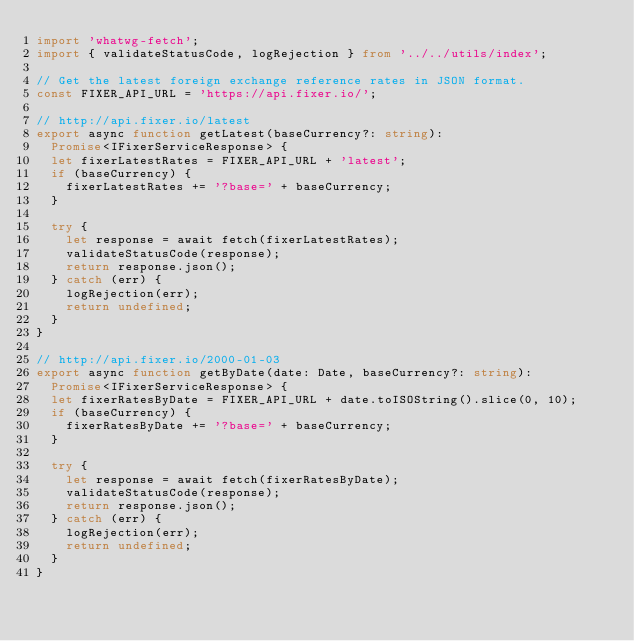<code> <loc_0><loc_0><loc_500><loc_500><_TypeScript_>import 'whatwg-fetch';
import { validateStatusCode, logRejection } from '../../utils/index';

// Get the latest foreign exchange reference rates in JSON format.
const FIXER_API_URL = 'https://api.fixer.io/';

// http://api.fixer.io/latest
export async function getLatest(baseCurrency?: string):
  Promise<IFixerServiceResponse> {
  let fixerLatestRates = FIXER_API_URL + 'latest';
  if (baseCurrency) {
    fixerLatestRates += '?base=' + baseCurrency;
  }

  try {
    let response = await fetch(fixerLatestRates);
    validateStatusCode(response);
    return response.json();
  } catch (err) {
    logRejection(err);
    return undefined;
  }
}

// http://api.fixer.io/2000-01-03
export async function getByDate(date: Date, baseCurrency?: string):
  Promise<IFixerServiceResponse> {
  let fixerRatesByDate = FIXER_API_URL + date.toISOString().slice(0, 10);
  if (baseCurrency) {
    fixerRatesByDate += '?base=' + baseCurrency;
  }

  try {
    let response = await fetch(fixerRatesByDate);
    validateStatusCode(response);
    return response.json();
  } catch (err) {
    logRejection(err);
    return undefined;
  }
}
</code> 